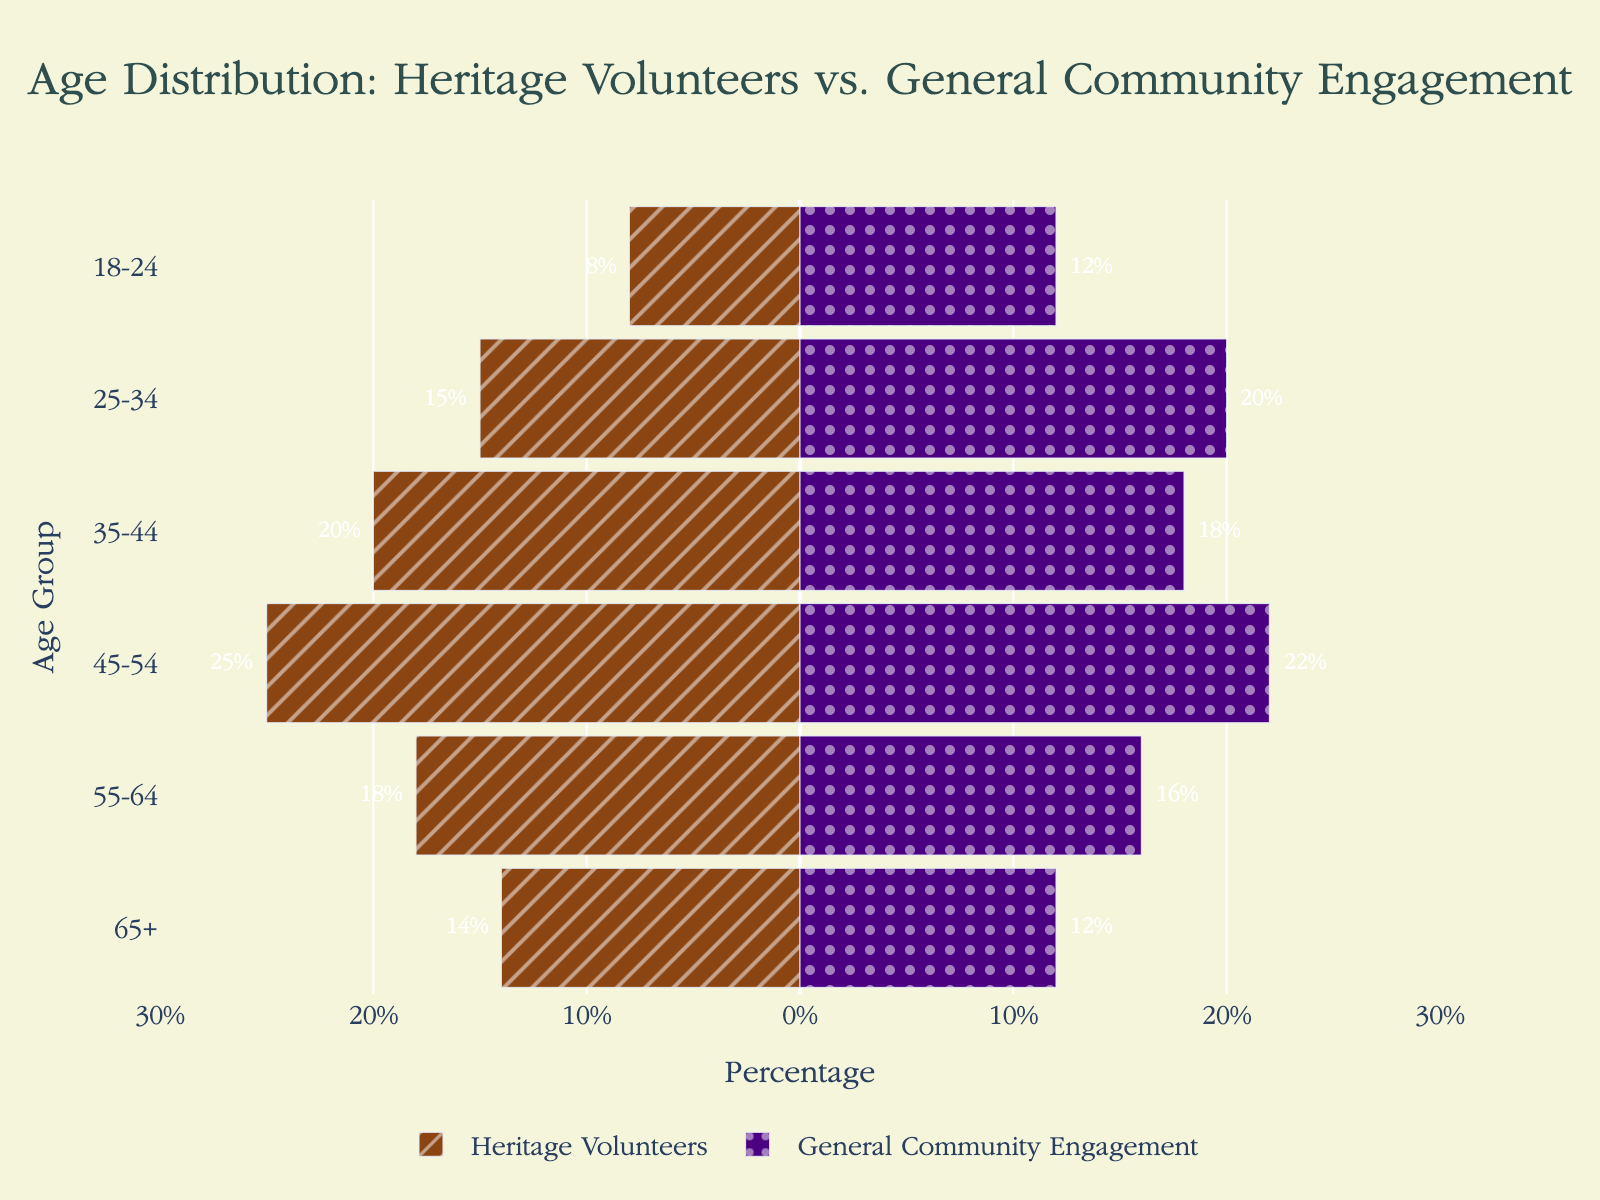What's the age group with the smallest percentage of heritage volunteers? Look at the length of the bars on the negative side of the chart, which represent heritage volunteers. The shortest bar is for the age group 18-24, with a percentage of 8%.
Answer: 18-24 Between which age groups are heritage volunteers and general community engagement most similar? Compare the bars on both sides for each age group. The 55-64 age group has the smallest difference, with 18% for heritage volunteers and 16% for general community engagement.
Answer: 55-64 What is the difference in the percentage of heritage volunteers between the 35-44 and 65+ age groups? Find the bars for the 35-44 and 65+ age groups on the negative side. The percentage for 35-44 is 20% and for 65+ is 14%. Calculate the difference: 20% - 14% = 6%.
Answer: 6% Which age group has a higher percentage in general community engagement compared to heritage volunteers, and by how much? Identify the bars where the positive side (general community engagement) exceeds the negative side (heritage volunteers). For the 25-34 age group, general community engagement is 20% and heritage volunteers is 15%, so the difference is 20% - 15% = 5%.
Answer: 25-34, 5% How does the percentage of heritage volunteers for the age group 45-54 compare to the general community engagement percentage for the same group? Look at the length of the bars for the 45-54 age group. The heritage volunteers percentage is 25%, and the general community engagement percentage is 22%.
Answer: Heritage volunteer percentage is higher by 3% What is the total percentage representation of heritage volunteers in the age group 18-24 and 25-34? Find the values for the 18-24 and 25-34 age groups. Add them together: 8% + 15% = 23%.
Answer: 23% What is the sum of the percentages of general community engagement for the age groups 45-54 and 55-64? Look at the values for the age groups 45-54 and 55-64 on the positive side. Add them together: 22% + 16% = 38%.
Answer: 38% In which age group is the difference between heritage volunteers and general community engagement the greatest? Compare the differences for each age group. The age group 18-24 has the largest difference, with 12% - 8% = 4%. This turns out to be the greatest absolute difference.
Answer: 18-24 Which has a higher overall percentage, heritage volunteers or general community engagement for the age groups 35-44 and 65+ combined? Add the percentages for heritage volunteers: 20% + 14% = 34%. Add the percentages for general community engagement: 18% + 12% = 30%. Compare the sums.
Answer: Heritage volunteers What percentage of the community engagement for the 45-54 age group is left if the percentage of heritage volunteers in the same group is subtracted? The percentage for heritage volunteers is 25%, and for general community engagement is 22%. Subtract the heritage volunteers: 22% - 25% = -3%.
Answer: -3% 